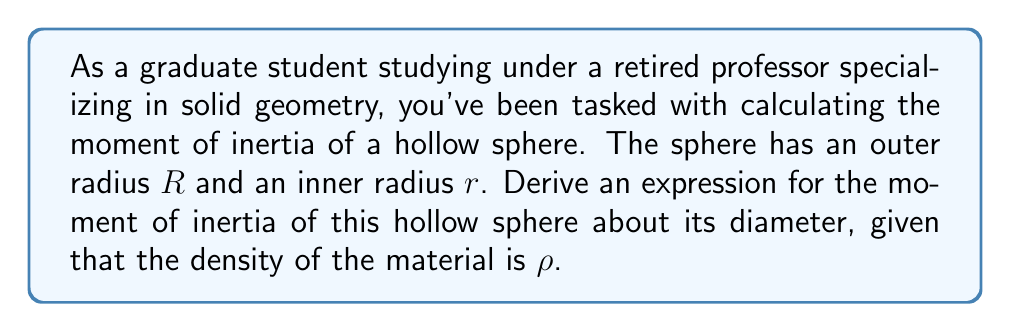Solve this math problem. To solve this problem, we'll follow these steps:

1) First, recall the formula for the moment of inertia of a solid sphere about its diameter:

   $$I_{solid} = \frac{2}{5}MR^2$$

   where $M$ is the mass of the sphere and $R$ is its radius.

2) For a hollow sphere, we can use the principle of superposition. We'll subtract the moment of inertia of the inner "missing" sphere from that of the outer sphere.

3) The mass of a sphere is given by $M = \frac{4}{3}\pi R^3 \rho$. So, the masses of the outer and inner spheres are:

   $$M_{outer} = \frac{4}{3}\pi R^3 \rho$$
   $$M_{inner} = \frac{4}{3}\pi r^3 \rho$$

4) The mass of the hollow sphere is the difference:

   $$M = M_{outer} - M_{inner} = \frac{4}{3}\pi \rho (R^3 - r^3)$$

5) Now, let's calculate the moment of inertia:

   $$I = I_{outer} - I_{inner}$$
   $$I = \frac{2}{5}M_{outer}R^2 - \frac{2}{5}M_{inner}r^2$$

6) Substituting the masses:

   $$I = \frac{2}{5}(\frac{4}{3}\pi R^3 \rho)R^2 - \frac{2}{5}(\frac{4}{3}\pi r^3 \rho)r^2$$

7) Simplifying:

   $$I = \frac{8}{15}\pi \rho (R^5 - r^5)$$

8) We can factor out $R^5$:

   $$I = \frac{8}{15}\pi \rho R^5 (1 - (\frac{r}{R})^5)$$

This is the final expression for the moment of inertia of a hollow sphere about its diameter.
Answer: $$I = \frac{8}{15}\pi \rho R^5 (1 - (\frac{r}{R})^5)$$ 